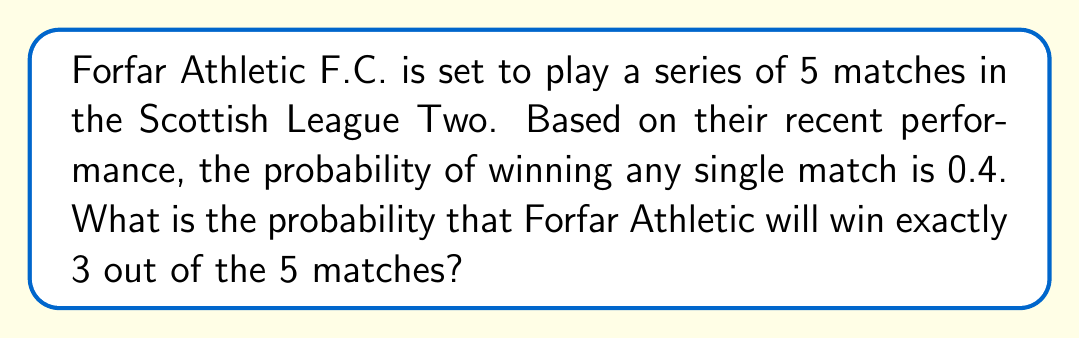Could you help me with this problem? To solve this problem, we need to use the binomial probability formula, as we're dealing with a fixed number of independent trials (matches) with two possible outcomes (win or not win) for each trial.

The binomial probability formula is:

$$ P(X = k) = \binom{n}{k} p^k (1-p)^{n-k} $$

Where:
$n$ = number of trials (matches) = 5
$k$ = number of successes (wins) = 3
$p$ = probability of success (winning a single match) = 0.4

Step 1: Calculate the binomial coefficient $\binom{n}{k}$
$$ \binom{5}{3} = \frac{5!}{3!(5-3)!} = \frac{5 \cdot 4}{2 \cdot 1} = 10 $$

Step 2: Calculate $p^k$
$$ 0.4^3 = 0.064 $$

Step 3: Calculate $(1-p)^{n-k}$
$$ (1-0.4)^{5-3} = 0.6^2 = 0.36 $$

Step 4: Multiply all parts together
$$ 10 \cdot 0.064 \cdot 0.36 = 0.2304 $$

Therefore, the probability of Forfar Athletic F.C. winning exactly 3 out of 5 matches is 0.2304 or 23.04%.
Answer: 0.2304 